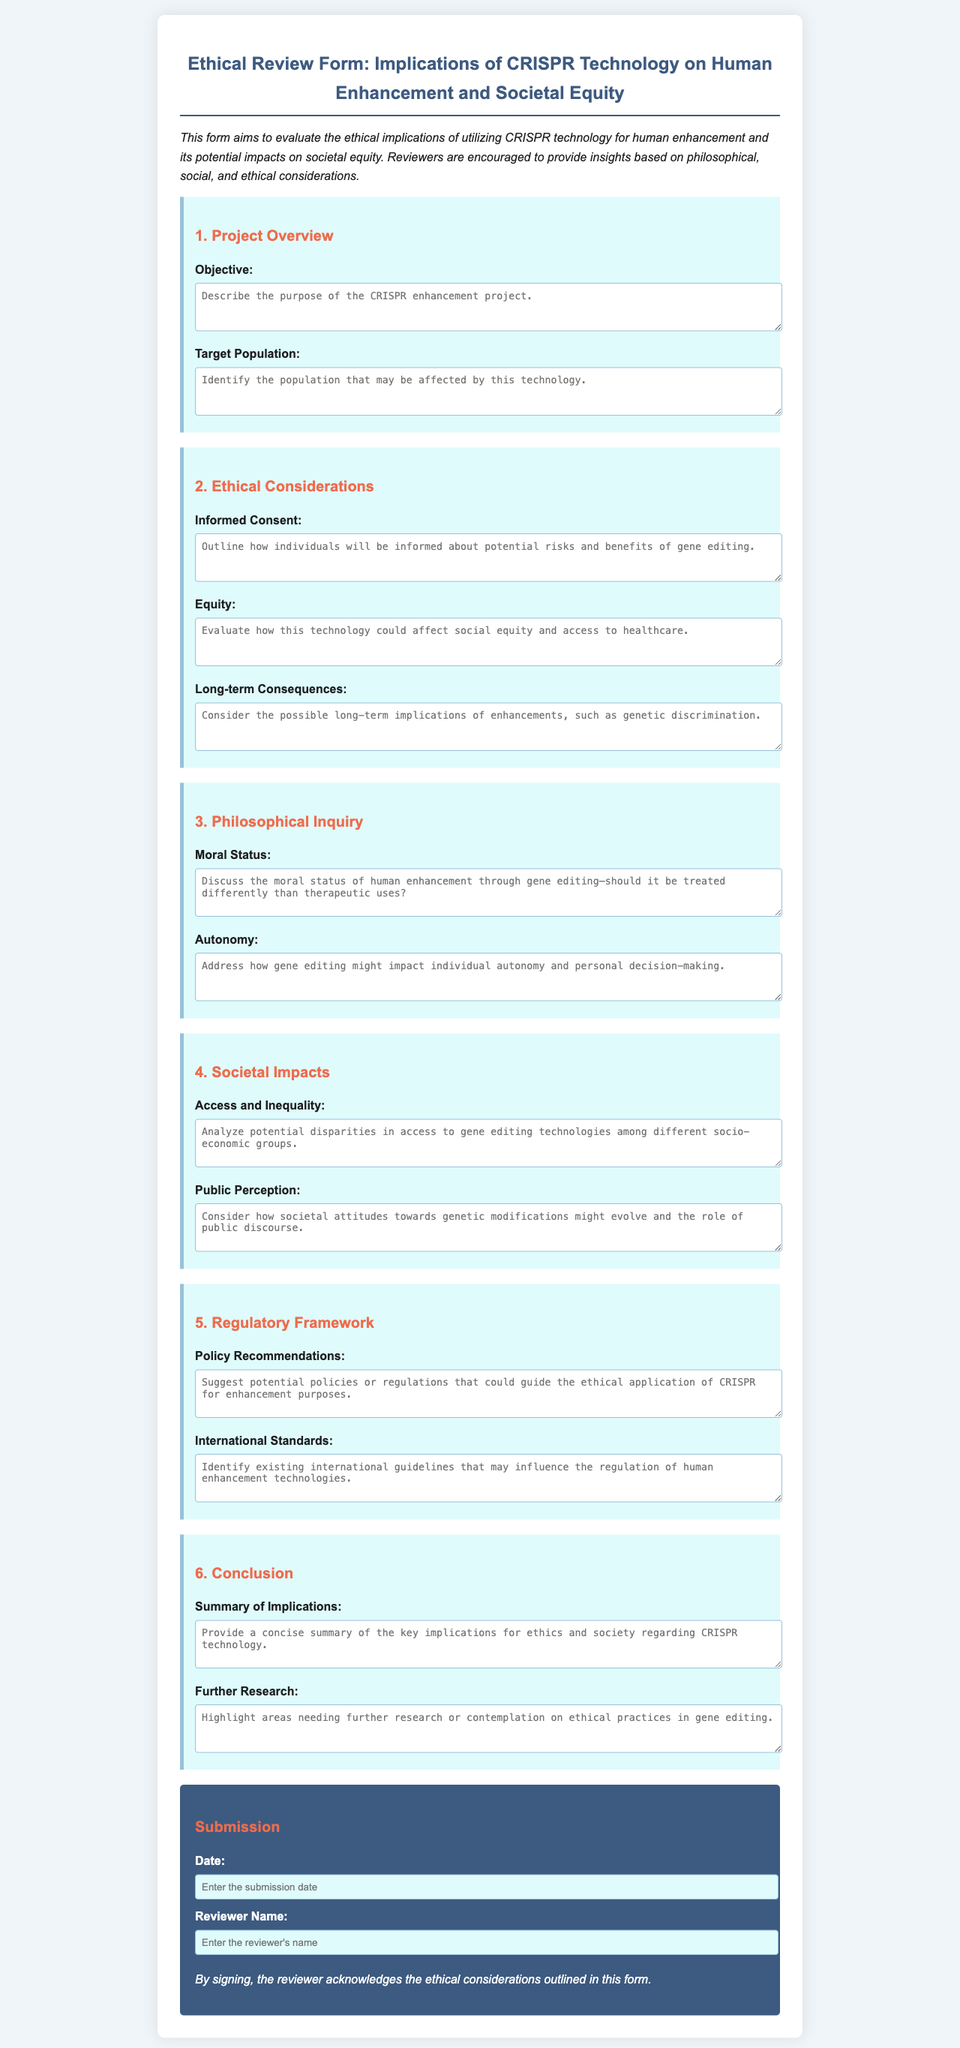What is the title of the document? The title is the main heading that identifies the document, which is "Ethical Review Form: Implications of CRISPR Technology on Human Enhancement and Societal Equity."
Answer: Ethical Review Form: Implications of CRISPR Technology on Human Enhancement and Societal Equity Who is the intended audience for the form? The intended audience includes individuals evaluating the ethical implications of utilizing CRISPR technology as stated in the introduction.
Answer: Reviewers What section discusses the moral status of human enhancement? The moral status of human enhancement is addressed in the section titled "Philosophical Inquiry."
Answer: Philosophical Inquiry What are the two aspects considered in the "Societal Impacts" section? The "Societal Impacts" section consists of addressing "Access and Inequality" and "Public Perception."
Answer: Access and Inequality, Public Perception What does the form require in the "Conclusion" section? The form requests a summary of the implications as well as areas needing further research on ethical practices in gene editing.
Answer: Summary of Implications, Further Research What is the placeholder text in the "Objective" field? The placeholder text provides guidance for the type of response expected, asking to describe the purpose of the CRISPR enhancement project.
Answer: Describe the purpose of the CRISPR enhancement project What color is used for the section headers? The section headers are colored in a shade of orange, as indicated by the Hex code #ee6c4d in the styling section.
Answer: Orange What does the reviewer acknowledge by signing the form? By signing the form, the reviewer acknowledges the ethical considerations outlined in the form.
Answer: Ethical considerations outlined in this form 